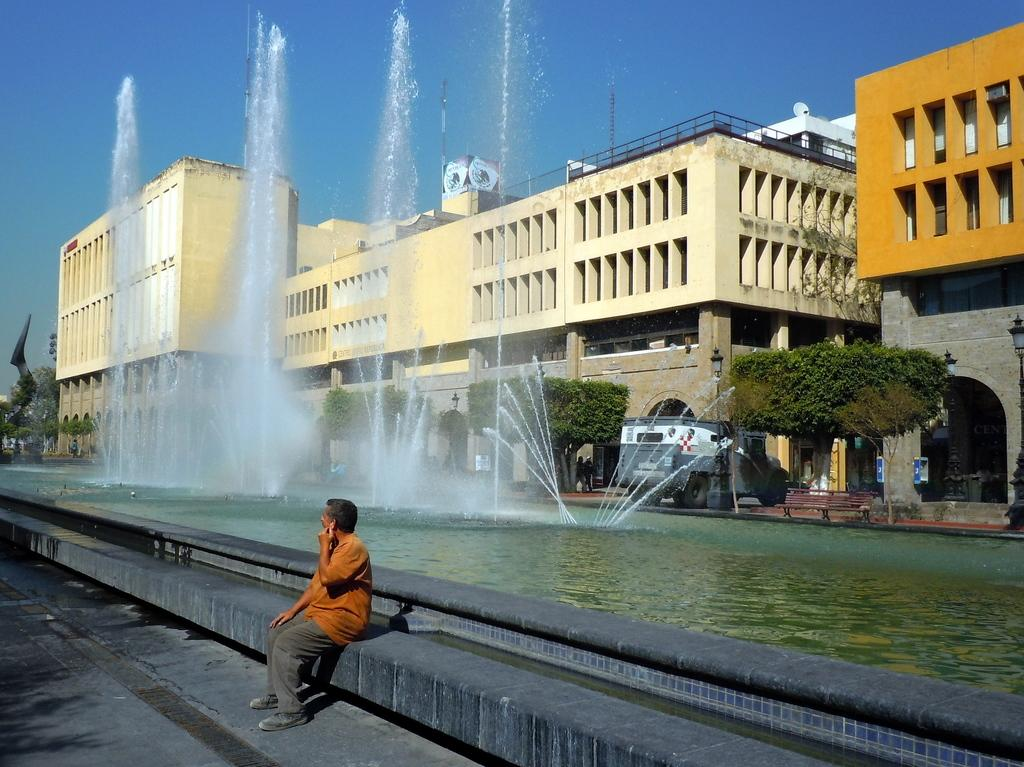What is the main subject in the foreground of the image? There is a person sitting at the fountain in the center of the image. What can be seen in the background of the image? There is a fountain, buildings, current poles, trees, a vehicle, and persons visible in the background of the image. What is the condition of the sky in the image? The sky is visible in the background of the image. What type of plate is being used by the mother in the image? There is no mother or plate present in the image. What day of the week is it in the image? The day of the week cannot be determined from the image. 